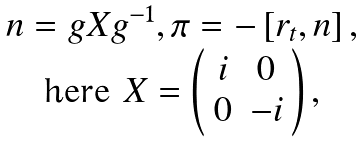Convert formula to latex. <formula><loc_0><loc_0><loc_500><loc_500>\begin{array} { c } n = g X g ^ { - 1 } , \pi = - \left [ r _ { t } , n \right ] , \\ \text {here } X = \left ( \begin{array} { c c } i & 0 \\ 0 & - i \end{array} \right ) , \end{array}</formula> 